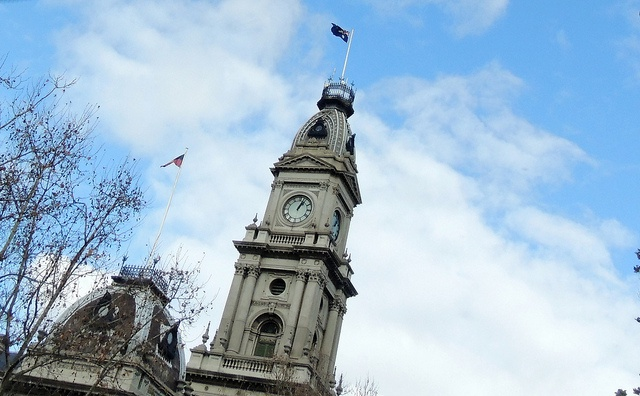Describe the objects in this image and their specific colors. I can see clock in lightblue, darkgray, gray, black, and lightgray tones and clock in lightblue, gray, black, and blue tones in this image. 